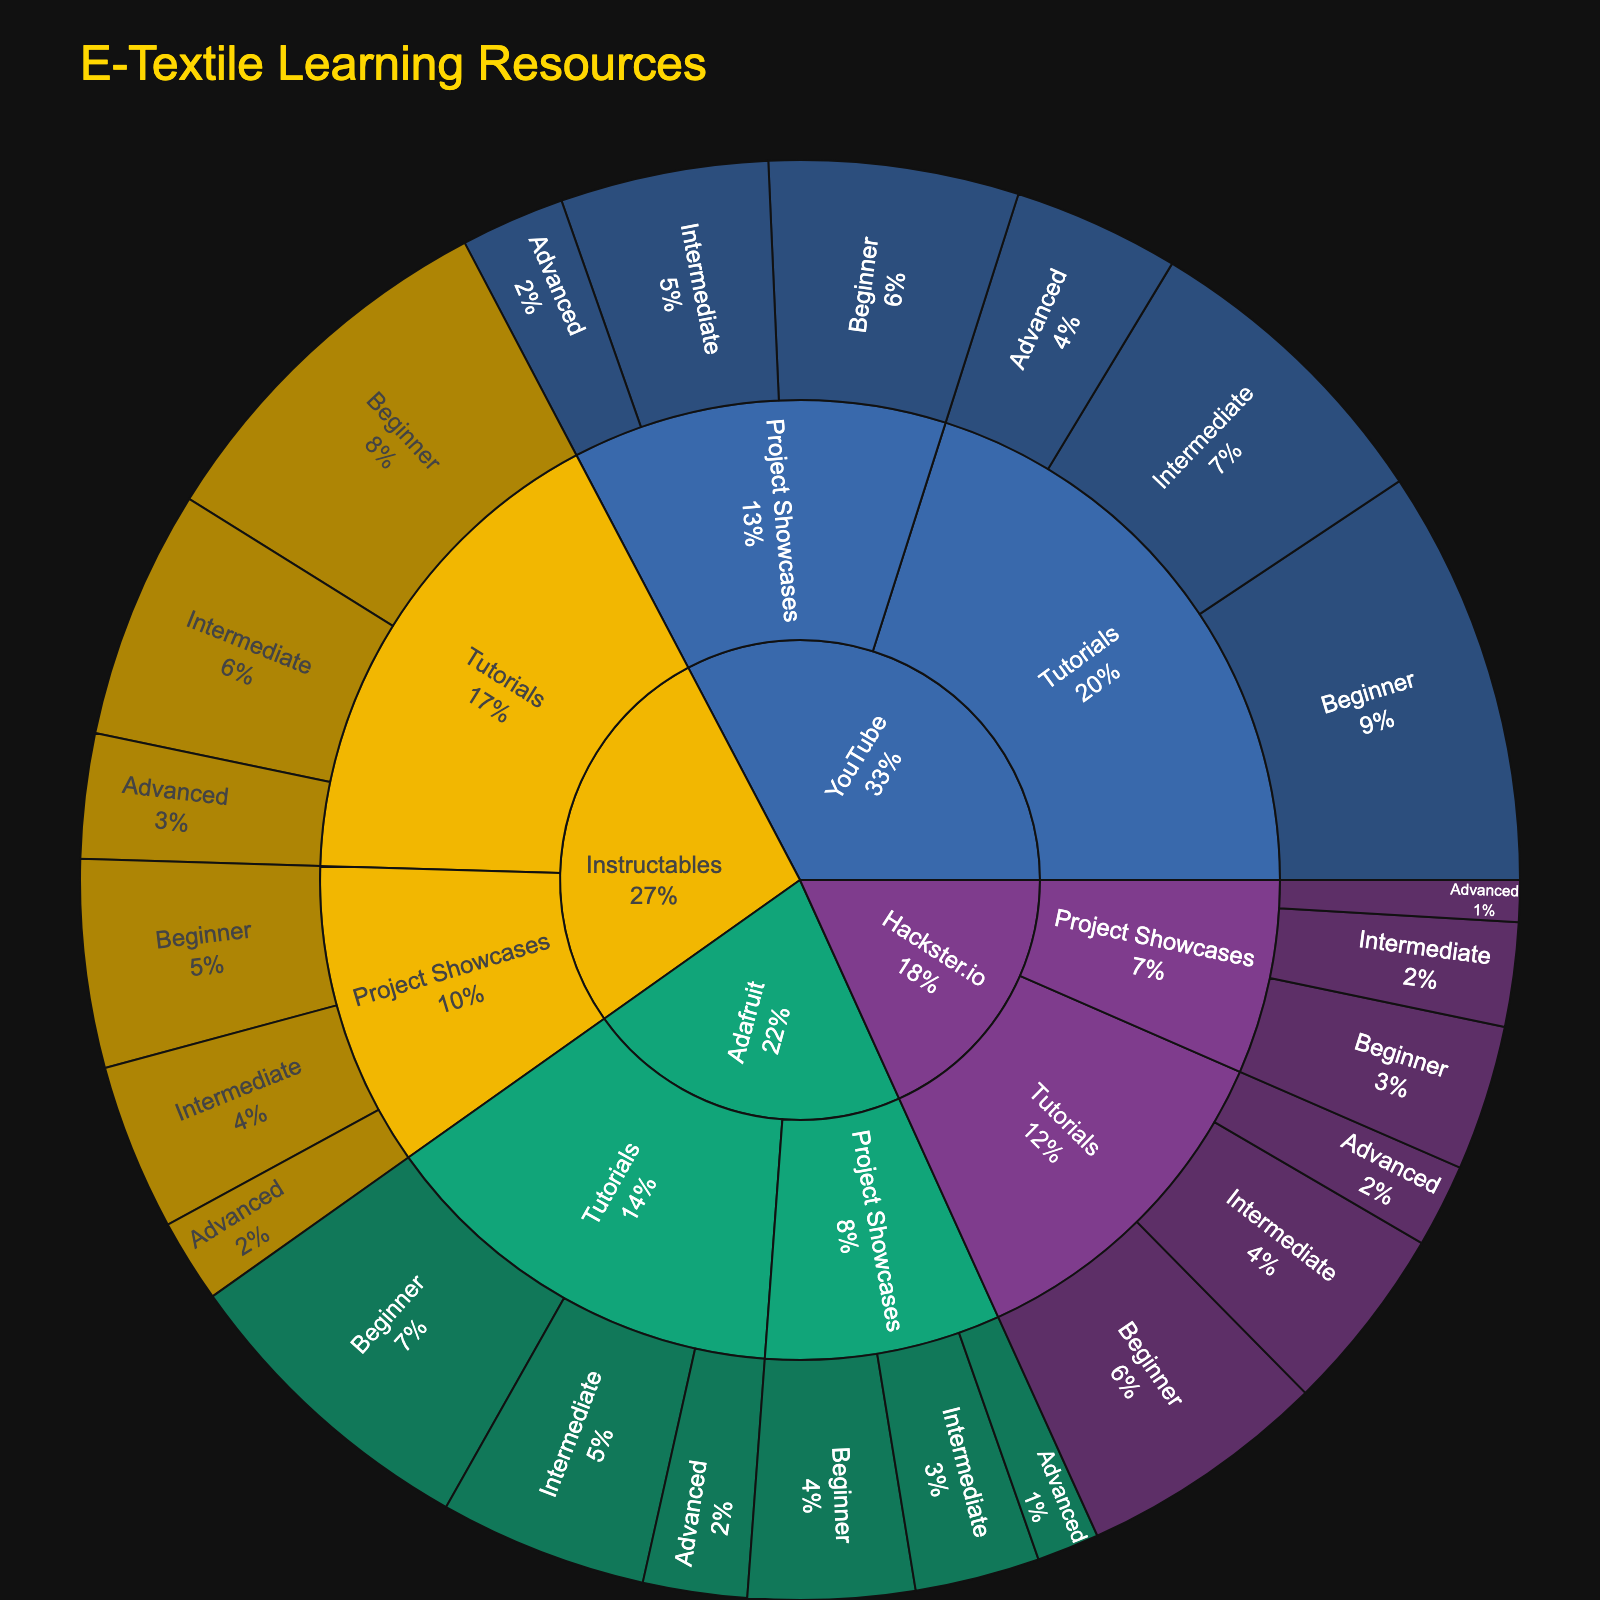What platform has the most beginner tutorials? Look at the 'Beginner' section under each platform and compare the values. YouTube has 20 beginner tutorials, which is the highest among all platforms.
Answer: YouTube Which content type has more intermediate-level resources on YouTube, Tutorials or Project Showcases? For intermediate level on YouTube, Tutorials have 15 resources while Project Showcases have 10 resources. Therefore, Tutorials have more intermediate-level resources.
Answer: Tutorials What is the total number of advanced tutorials across all platforms? Add up the advanced tutorials: YouTube (8), Instructables (6), Adafruit (5), Hackster.io (4). The total is 8 + 6 + 5 + 4 = 23.
Answer: 23 Which platform has the least number of project showcases? Compare the total 'Project Showcases' values for each platform. Hackster.io has 7 + 5 + 2 = 14 Project Showcases, which is the least.
Answer: Hackster.io What's the proportion of beginner-level tutorials on Instructables compared to the total beginner-level tutorials across all platforms? First, find the total beginner-level tutorials: YouTube (20), Instructables (18), Adafruit (15), Hackster.io (12). The sum is 20 + 18 + 15 + 12 = 65. The proportion for Instructables is 18 / 65.
Answer: 18/65 Between Adafruit and Hackster.io, which has more intermediate project showcases? Compare intermediate project showcases for both: Adafruit has 6, while Hackster.io has 5. Thus, Adafruit has more.
Answer: Adafruit How many total resources does YouTube offer, regardless of type and difficulty? Sum all the values for YouTube: Tutorials (20 + 15 + 8) and Project Showcases (12 + 10 + 5). The total is 20 + 15 + 8 + 12 + 10 + 5 = 70.
Answer: 70 What is the ratio of beginner to advanced project showcases on Instructables? On Instructables, Beginner Project Showcases are 10 and Advanced Project Showcases are 4. The ratio is 10:4, which simplifies to 5:2.
Answer: 5:2 